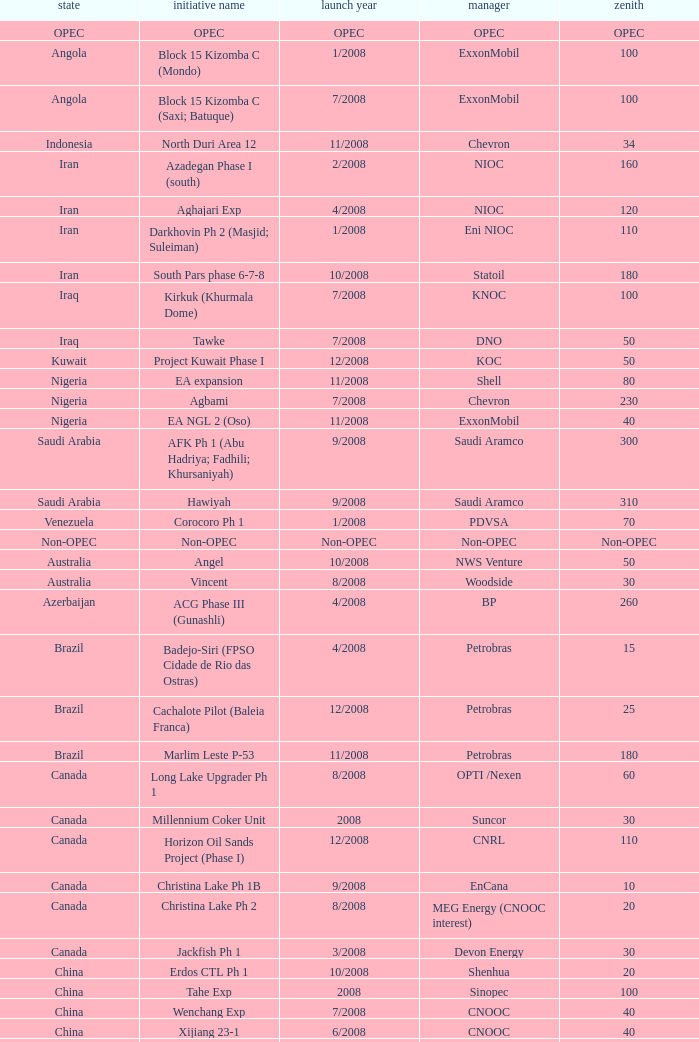Parse the table in full. {'header': ['state', 'initiative name', 'launch year', 'manager', 'zenith'], 'rows': [['OPEC', 'OPEC', 'OPEC', 'OPEC', 'OPEC'], ['Angola', 'Block 15 Kizomba C (Mondo)', '1/2008', 'ExxonMobil', '100'], ['Angola', 'Block 15 Kizomba C (Saxi; Batuque)', '7/2008', 'ExxonMobil', '100'], ['Indonesia', 'North Duri Area 12', '11/2008', 'Chevron', '34'], ['Iran', 'Azadegan Phase I (south)', '2/2008', 'NIOC', '160'], ['Iran', 'Aghajari Exp', '4/2008', 'NIOC', '120'], ['Iran', 'Darkhovin Ph 2 (Masjid; Suleiman)', '1/2008', 'Eni NIOC', '110'], ['Iran', 'South Pars phase 6-7-8', '10/2008', 'Statoil', '180'], ['Iraq', 'Kirkuk (Khurmala Dome)', '7/2008', 'KNOC', '100'], ['Iraq', 'Tawke', '7/2008', 'DNO', '50'], ['Kuwait', 'Project Kuwait Phase I', '12/2008', 'KOC', '50'], ['Nigeria', 'EA expansion', '11/2008', 'Shell', '80'], ['Nigeria', 'Agbami', '7/2008', 'Chevron', '230'], ['Nigeria', 'EA NGL 2 (Oso)', '11/2008', 'ExxonMobil', '40'], ['Saudi Arabia', 'AFK Ph 1 (Abu Hadriya; Fadhili; Khursaniyah)', '9/2008', 'Saudi Aramco', '300'], ['Saudi Arabia', 'Hawiyah', '9/2008', 'Saudi Aramco', '310'], ['Venezuela', 'Corocoro Ph 1', '1/2008', 'PDVSA', '70'], ['Non-OPEC', 'Non-OPEC', 'Non-OPEC', 'Non-OPEC', 'Non-OPEC'], ['Australia', 'Angel', '10/2008', 'NWS Venture', '50'], ['Australia', 'Vincent', '8/2008', 'Woodside', '30'], ['Azerbaijan', 'ACG Phase III (Gunashli)', '4/2008', 'BP', '260'], ['Brazil', 'Badejo-Siri (FPSO Cidade de Rio das Ostras)', '4/2008', 'Petrobras', '15'], ['Brazil', 'Cachalote Pilot (Baleia Franca)', '12/2008', 'Petrobras', '25'], ['Brazil', 'Marlim Leste P-53', '11/2008', 'Petrobras', '180'], ['Canada', 'Long Lake Upgrader Ph 1', '8/2008', 'OPTI /Nexen', '60'], ['Canada', 'Millennium Coker Unit', '2008', 'Suncor', '30'], ['Canada', 'Horizon Oil Sands Project (Phase I)', '12/2008', 'CNRL', '110'], ['Canada', 'Christina Lake Ph 1B', '9/2008', 'EnCana', '10'], ['Canada', 'Christina Lake Ph 2', '8/2008', 'MEG Energy (CNOOC interest)', '20'], ['Canada', 'Jackfish Ph 1', '3/2008', 'Devon Energy', '30'], ['China', 'Erdos CTL Ph 1', '10/2008', 'Shenhua', '20'], ['China', 'Tahe Exp', '2008', 'Sinopec', '100'], ['China', 'Wenchang Exp', '7/2008', 'CNOOC', '40'], ['China', 'Xijiang 23-1', '6/2008', 'CNOOC', '40'], ['Congo', 'Moho Bilondo', '4/2008', 'Total', '90'], ['Egypt', 'Saqqara', '3/2008', 'BP', '40'], ['India', 'MA field (KG-D6)', '9/2008', 'Reliance', '40'], ['Kazakhstan', 'Dunga', '3/2008', 'Maersk', '150'], ['Kazakhstan', 'Komsomolskoe', '5/2008', 'Petrom', '10'], ['Mexico', '( Chicontepec ) Exp 1', '2008', 'PEMEX', '200'], ['Mexico', 'Antonio J Bermudez Exp', '5/2008', 'PEMEX', '20'], ['Mexico', 'Bellota Chinchorro Exp', '5/2008', 'PEMEX', '20'], ['Mexico', 'Ixtal Manik', '2008', 'PEMEX', '55'], ['Mexico', 'Jujo Tecominoacan Exp', '2008', 'PEMEX', '15'], ['Norway', 'Alvheim; Volund; Vilje', '6/2008', 'Marathon', '100'], ['Norway', 'Volve', '2/2008', 'StatoilHydro', '35'], ['Oman', 'Mukhaizna EOR Ph 1', '2008', 'Occidental', '40'], ['Philippines', 'Galoc', '10/2008', 'GPC', '15'], ['Russia', 'Talakan Ph 1', '10/2008', 'Surgutneftegaz', '60'], ['Russia', 'Verkhnechonsk Ph 1 (early oil)', '10/2008', 'TNK-BP Rosneft', '20'], ['Russia', 'Yuzhno-Khylchuyuskoye "YK" Ph 1', '8/2008', 'Lukoil ConocoPhillips', '75'], ['Thailand', 'Bualuang', '8/2008', 'Salamander', '10'], ['UK', 'Britannia Satellites (Callanish; Brodgar)', '7/2008', 'Conoco Phillips', '25'], ['USA', 'Blind Faith', '11/2008', 'Chevron', '45'], ['USA', 'Neptune', '7/2008', 'BHP Billiton', '25'], ['USA', 'Oooguruk', '6/2008', 'Pioneer', '15'], ['USA', 'Qannik', '7/2008', 'ConocoPhillips', '4'], ['USA', 'Thunder Horse', '6/2008', 'BP', '210'], ['USA', 'Ursa Princess Exp', '1/2008', 'Shell', '30'], ['Vietnam', 'Ca Ngu Vang (Golden Tuna)', '7/2008', 'HVJOC', '15'], ['Vietnam', 'Su Tu Vang', '10/2008', 'Cuu Long Joint', '40'], ['Vietnam', 'Song Doc', '12/2008', 'Talisman', '10']]} What is the Operator with a Peak that is 55? PEMEX. 